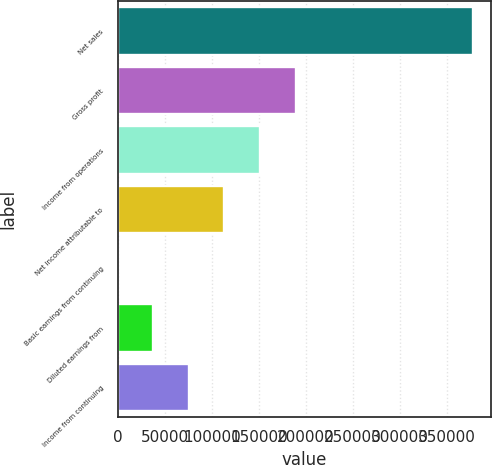Convert chart to OTSL. <chart><loc_0><loc_0><loc_500><loc_500><bar_chart><fcel>Net sales<fcel>Gross profit<fcel>Income from operations<fcel>Net income attributable to<fcel>Basic earnings from continuing<fcel>Diluted earnings from<fcel>Income from continuing<nl><fcel>377960<fcel>188980<fcel>151184<fcel>113388<fcel>0.68<fcel>37796.6<fcel>75592.5<nl></chart> 